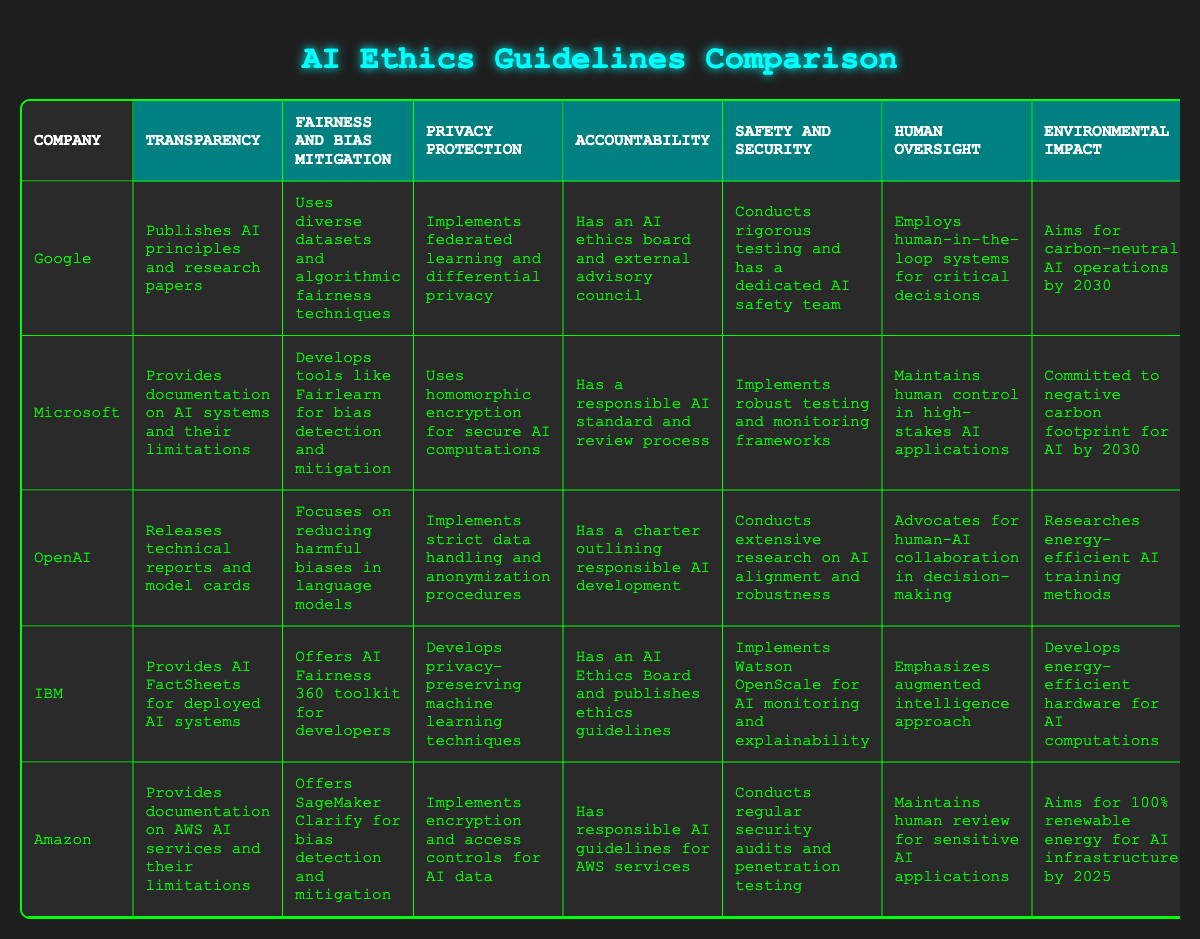What transparency methods does Google use in AI development? According to the table, Google publishes AI principles and research papers for transparency. This information is directly taken from the row corresponding to Google under the transparency category.
Answer: Publishes AI principles and research papers Which company focuses on human oversight in AI applications? The table shows that Microsoft maintains human control in high-stakes AI applications, while OpenAI advocates for human-AI collaboration in decision-making. Comparing these entries, both emphasize human oversight but in different contexts.
Answer: Microsoft and OpenAI What is the primary environmental goal of Amazon for its AI infrastructure? In the table, it states that Amazon aims for 100% renewable energy for AI infrastructure by 2025. This is found in the environmental impact category for Amazon.
Answer: 100% renewable energy by 2025 Does all companies have a commitment towards environmental impact? By checking the environmental impact row for each company, we notice that not all companies have a commitment listed. For example, Google and IBM focus on energy efficiency and carbon neutrality, while OpenAI focuses on energy-efficient training methods, and Amazon targets renewable energy, indicating a clear commitment across most but not all companies.
Answer: Yes Comparing the approaches of Microsoft and IBM, which company emphasizes privacy protection more? In the privacy protection category, Microsoft uses homomorphic encryption for secure AI computations, while IBM develops privacy-preserving machine learning techniques. Both approaches show a commitment to privacy, but they are distinct methods that are not directly comparable in effectiveness or focus from the provided data. As such, both are significant but differ in their protective measures.
Answer: Both have significant approaches What techniques does OpenAI implement for privacy protection? The table states that OpenAI implements strict data handling and anonymization procedures. This answer is derived directly from the table in the privacy protection category under OpenAI.
Answer: Strict data handling and anonymization procedures Which company has both an AI ethics board and publishes ethics guidelines? From the table, it’s clear that both IBM and Google have an AI ethics board, but only IBM is explicitly stated as publishing ethics guidelines. This distinction allows us to conclude that IBM fits this specific criteria better.
Answer: IBM What type of tools does Microsoft provide for fairness and bias mitigation? The table highlights that Microsoft develops tools like Fairlearn specifically for bias detection and mitigation, making it a concrete example of their approach. This answer can be found in the fairness and bias mitigation section under Microsoft.
Answer: Tools like Fairlearn for bias detection and mitigation 